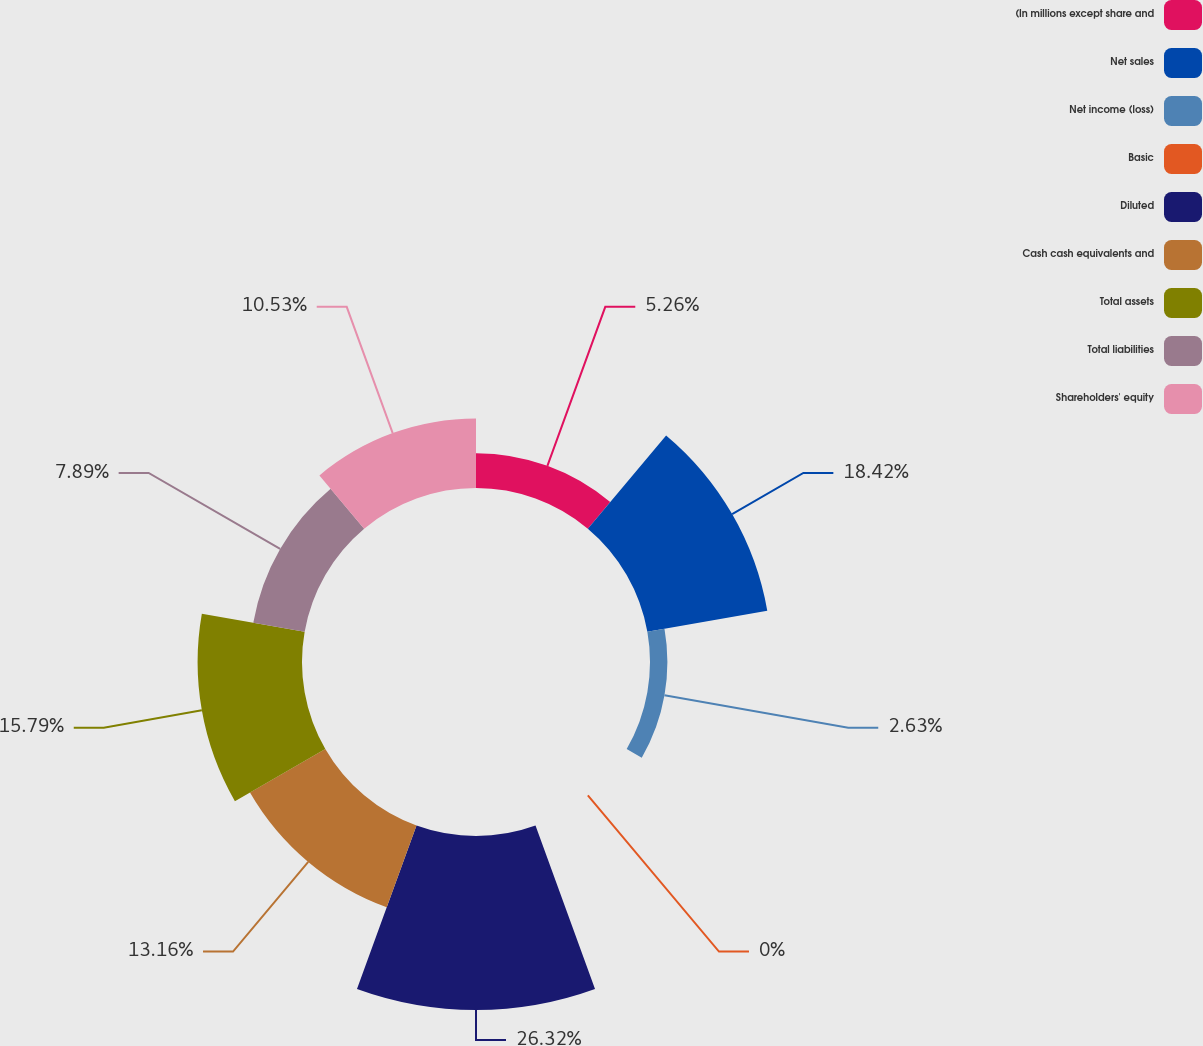Convert chart to OTSL. <chart><loc_0><loc_0><loc_500><loc_500><pie_chart><fcel>(In millions except share and<fcel>Net sales<fcel>Net income (loss)<fcel>Basic<fcel>Diluted<fcel>Cash cash equivalents and<fcel>Total assets<fcel>Total liabilities<fcel>Shareholders' equity<nl><fcel>5.26%<fcel>18.42%<fcel>2.63%<fcel>0.0%<fcel>26.32%<fcel>13.16%<fcel>15.79%<fcel>7.89%<fcel>10.53%<nl></chart> 